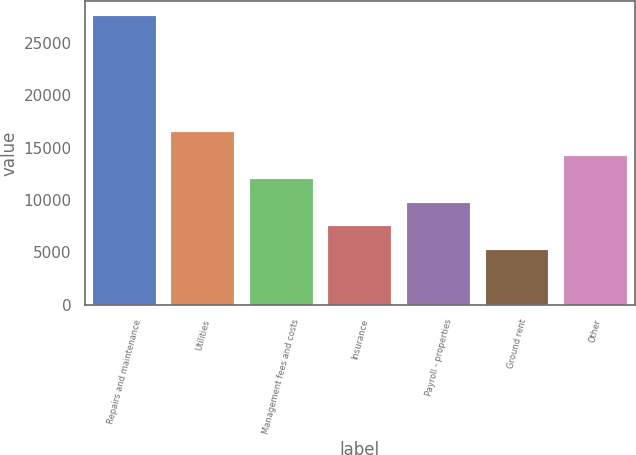<chart> <loc_0><loc_0><loc_500><loc_500><bar_chart><fcel>Repairs and maintenance<fcel>Utilities<fcel>Management fees and costs<fcel>Insurance<fcel>Payroll - properties<fcel>Ground rent<fcel>Other<nl><fcel>27617<fcel>16491.2<fcel>12024<fcel>7514.6<fcel>9748.2<fcel>5281<fcel>14257.6<nl></chart> 